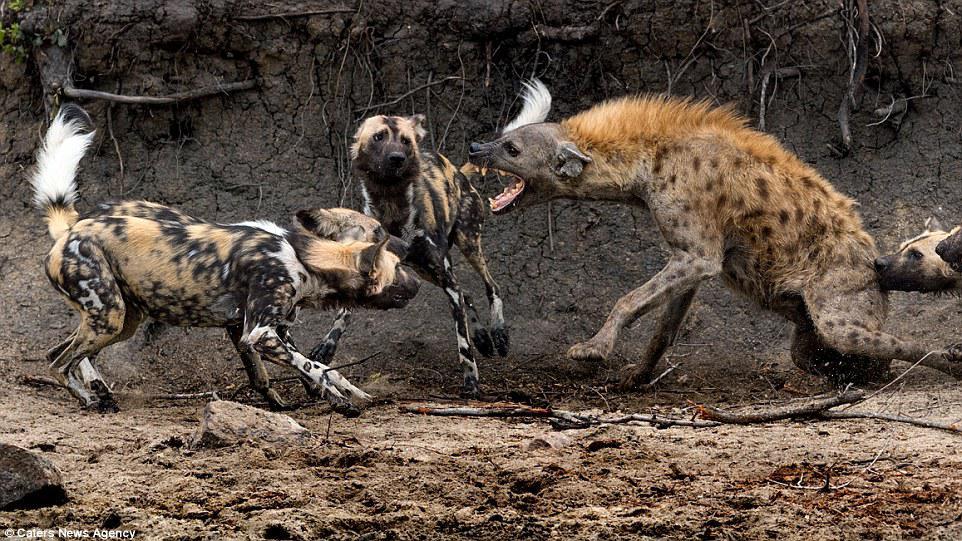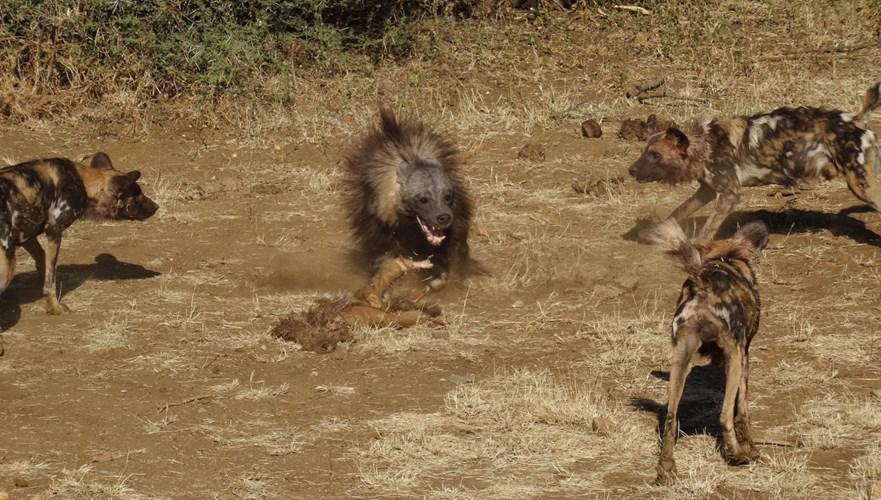The first image is the image on the left, the second image is the image on the right. Assess this claim about the two images: "Hyenas are by a body of water.". Correct or not? Answer yes or no. No. 